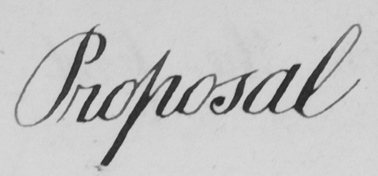What does this handwritten line say? Proposal 